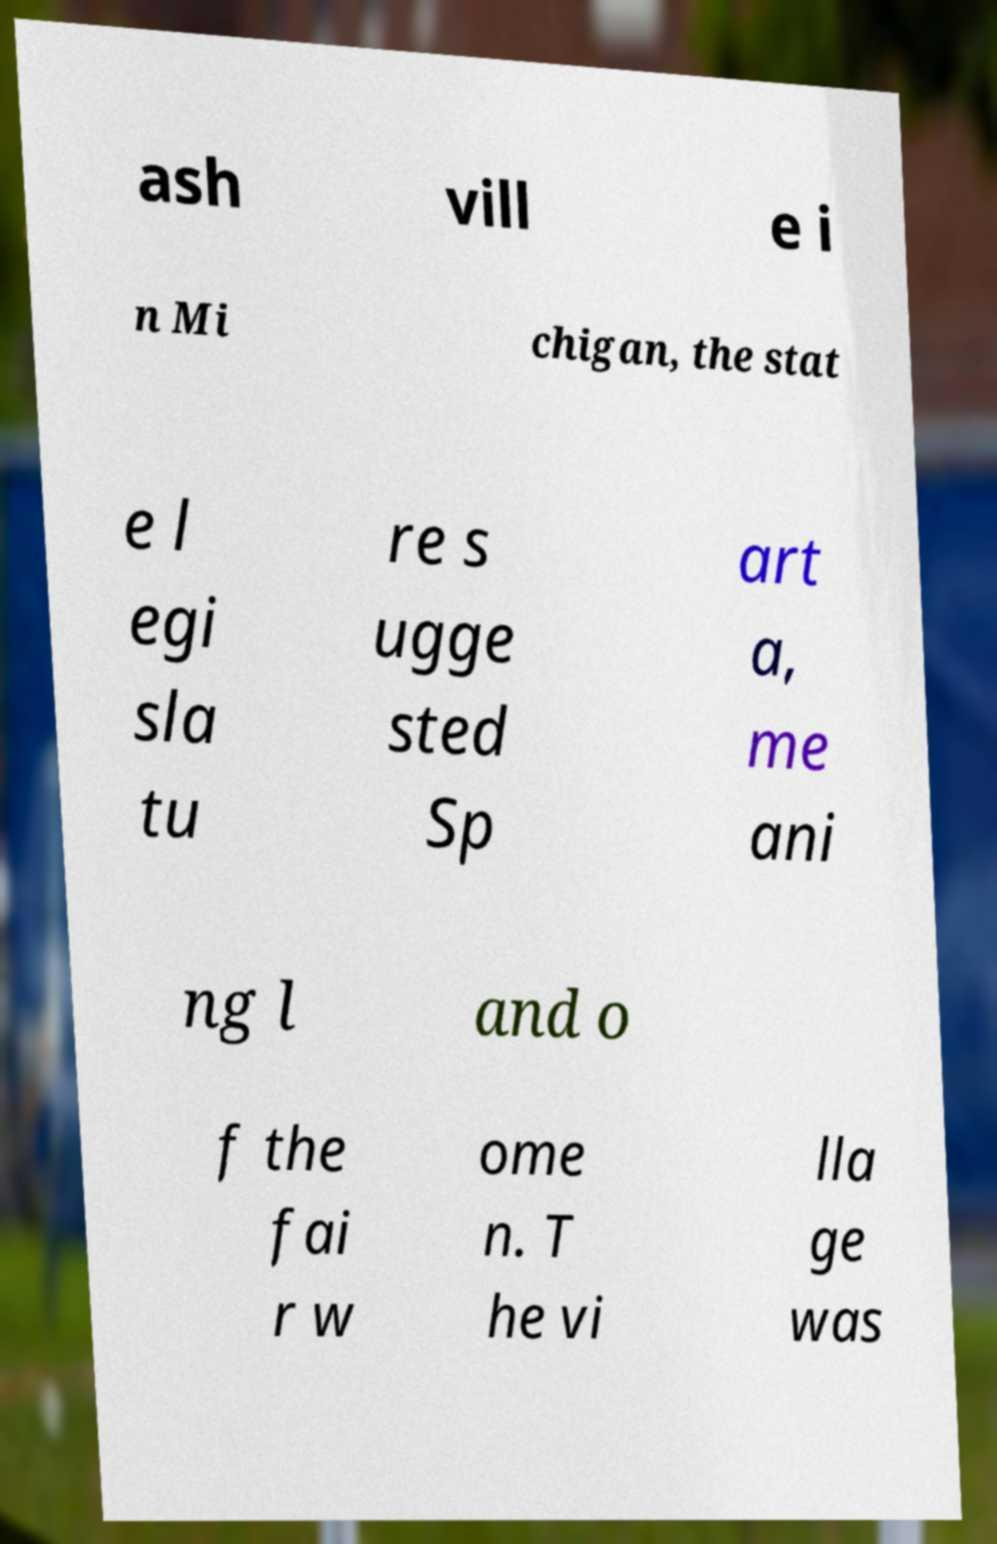Please identify and transcribe the text found in this image. ash vill e i n Mi chigan, the stat e l egi sla tu re s ugge sted Sp art a, me ani ng l and o f the fai r w ome n. T he vi lla ge was 